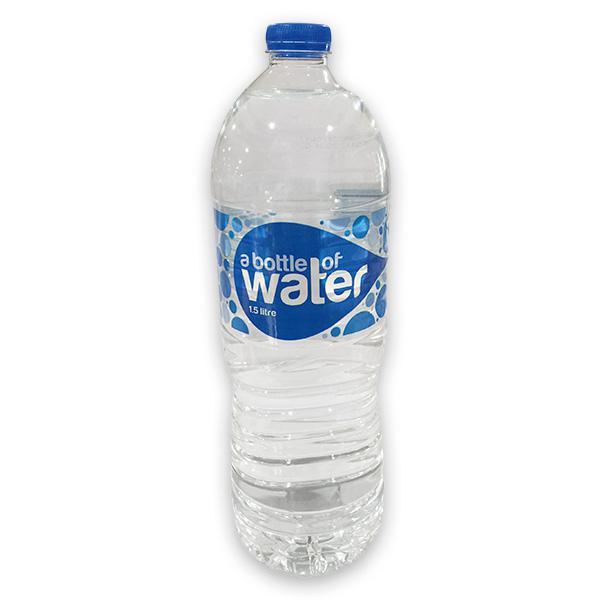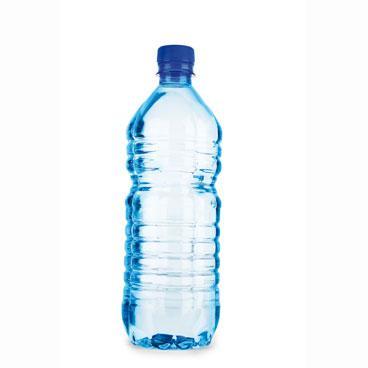The first image is the image on the left, the second image is the image on the right. Examine the images to the left and right. Is the description "At least one of the bottles doesn't have a lable." accurate? Answer yes or no. Yes. The first image is the image on the left, the second image is the image on the right. For the images displayed, is the sentence "Each image contains exactly one water bottle with a blue lid." factually correct? Answer yes or no. Yes. 